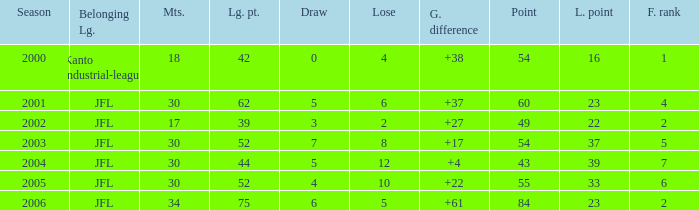I want the average lose for lost point more than 16 and goal difference less than 37 and point less than 43 None. 